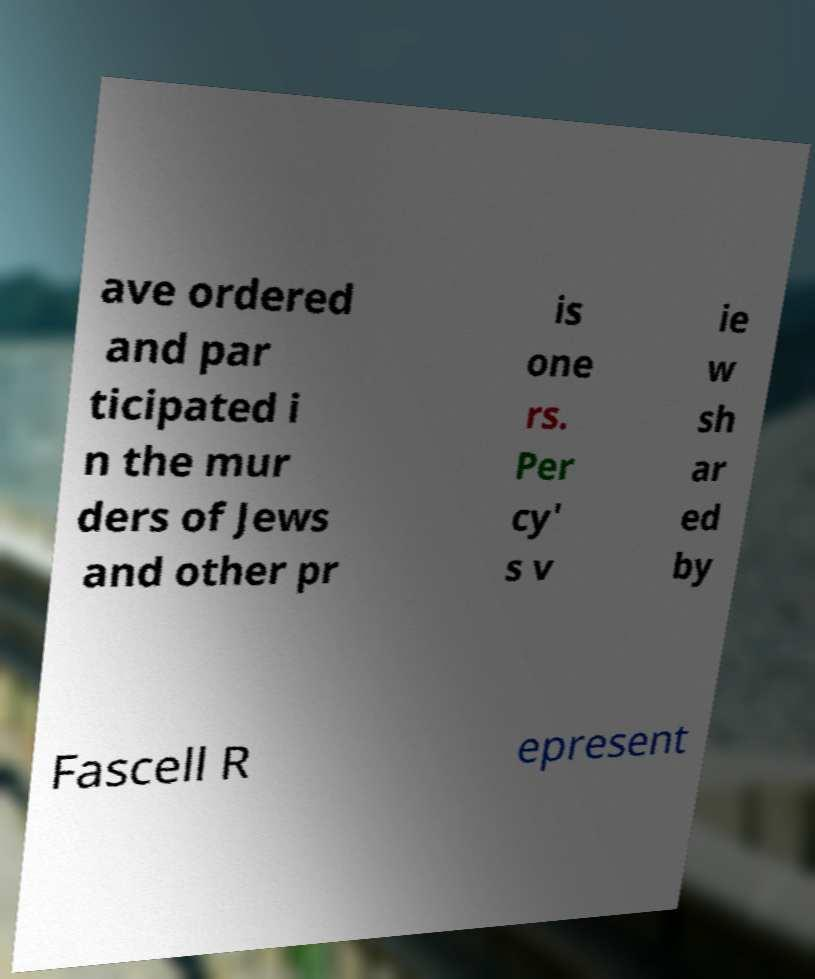Could you extract and type out the text from this image? ave ordered and par ticipated i n the mur ders of Jews and other pr is one rs. Per cy' s v ie w sh ar ed by Fascell R epresent 